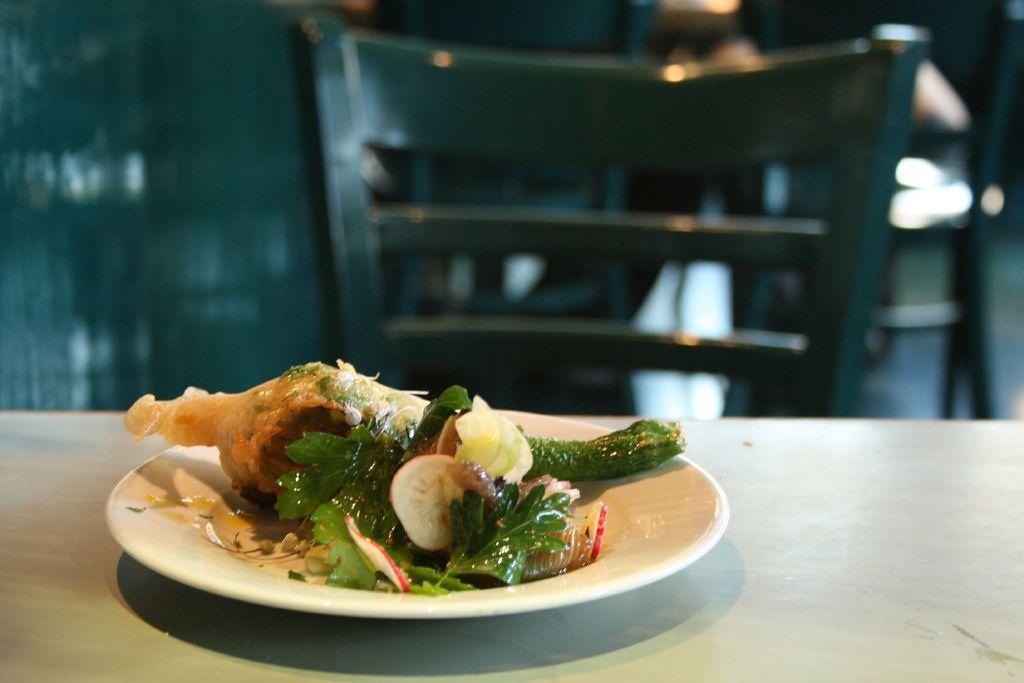Could you give a brief overview of what you see in this image? In this picture we can see food in a plate and the plate is on an object. Behind the plate, there is a chair and the blurred background. 